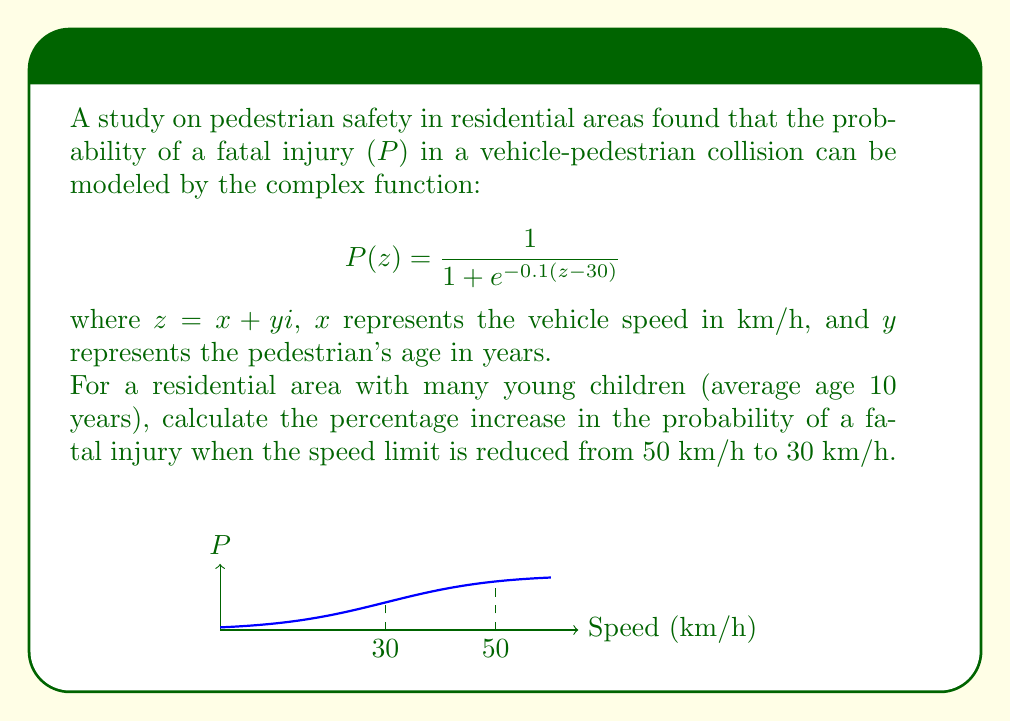Show me your answer to this math problem. Let's approach this step-by-step:

1) We need to evaluate $P(z)$ at two points: $z_1 = 50 + 10i$ and $z_2 = 30 + 10i$.

2) For $z_1 = 50 + 10i$:
   $$P(50 + 10i) = \frac{1}{1 + e^{-0.1((50+10i)-30)}} = \frac{1}{1 + e^{-2-i}}$$

3) For $z_2 = 30 + 10i$:
   $$P(30 + 10i) = \frac{1}{1 + e^{-0.1((30+10i)-30)}} = \frac{1}{1 + e^{-i}}$$

4) To calculate these complex values, we can use Euler's formula: $e^{ix} = \cos x + i\sin x$

5) For $P(50 + 10i)$:
   $$\frac{1}{1 + e^{-2}(\cos 1 - i\sin 1)} = \frac{1}{1 + 0.1353(\cos 1 - i\sin 1)} = 0.8475 - 0.0708i$$

6) For $P(30 + 10i)$:
   $$\frac{1}{1 + \cos 1 - i\sin 1} = 0.5 - 0.1592i$$

7) The probability of a fatal injury is given by the real part of these complex numbers.

8) At 50 km/h: $P_{50} = 0.8475$
   At 30 km/h: $P_{30} = 0.5$

9) The percentage decrease is:
   $$\frac{P_{50} - P_{30}}{P_{50}} \times 100\% = \frac{0.8475 - 0.5}{0.8475} \times 100\% = 41.00\%$$

Therefore, reducing the speed limit from 50 km/h to 30 km/h decreases the probability of a fatal injury by approximately 41.00%.
Answer: 41.00% decrease 